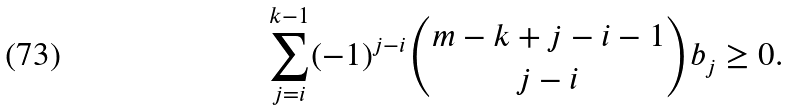<formula> <loc_0><loc_0><loc_500><loc_500>\sum _ { j = i } ^ { k - 1 } ( - 1 ) ^ { j - i } \binom { m - k + j - i - 1 } { j - i } b _ { j } \geq 0 .</formula> 